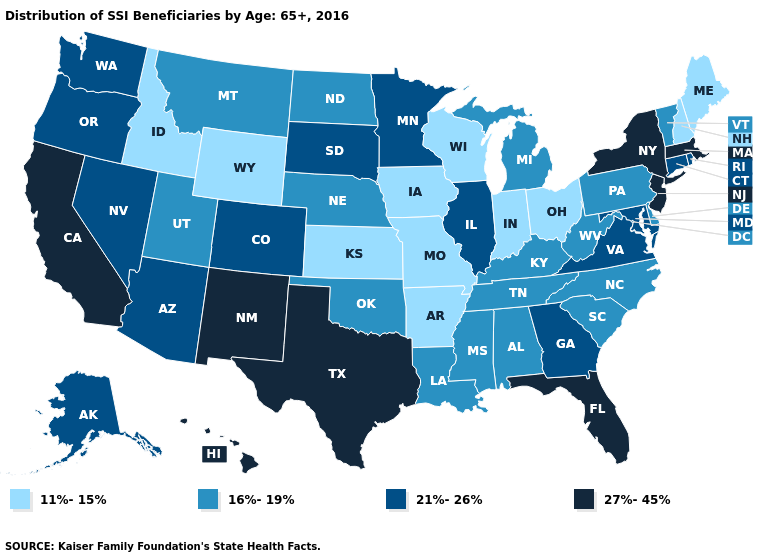Which states have the highest value in the USA?
Be succinct. California, Florida, Hawaii, Massachusetts, New Jersey, New Mexico, New York, Texas. Does Oklahoma have the lowest value in the USA?
Write a very short answer. No. What is the highest value in the West ?
Be succinct. 27%-45%. What is the value of Kansas?
Answer briefly. 11%-15%. What is the lowest value in states that border New Hampshire?
Short answer required. 11%-15%. Is the legend a continuous bar?
Concise answer only. No. Among the states that border Texas , does New Mexico have the highest value?
Write a very short answer. Yes. Among the states that border Minnesota , which have the highest value?
Short answer required. South Dakota. Does the first symbol in the legend represent the smallest category?
Give a very brief answer. Yes. Does Massachusetts have a higher value than California?
Be succinct. No. What is the lowest value in the South?
Write a very short answer. 11%-15%. Is the legend a continuous bar?
Be succinct. No. What is the value of West Virginia?
Keep it brief. 16%-19%. Does Colorado have the highest value in the West?
Answer briefly. No. What is the value of Alabama?
Give a very brief answer. 16%-19%. 